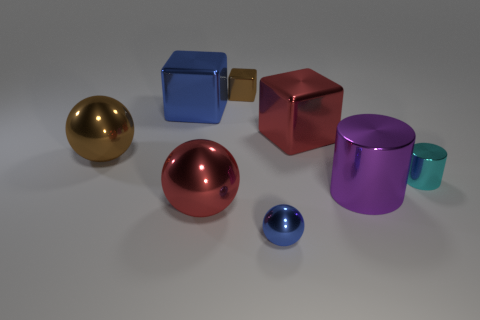Add 1 large brown metal things. How many objects exist? 9 Subtract all spheres. How many objects are left? 5 Add 3 tiny metallic cubes. How many tiny metallic cubes exist? 4 Subtract 0 gray cubes. How many objects are left? 8 Subtract all red metallic balls. Subtract all big objects. How many objects are left? 2 Add 8 cylinders. How many cylinders are left? 10 